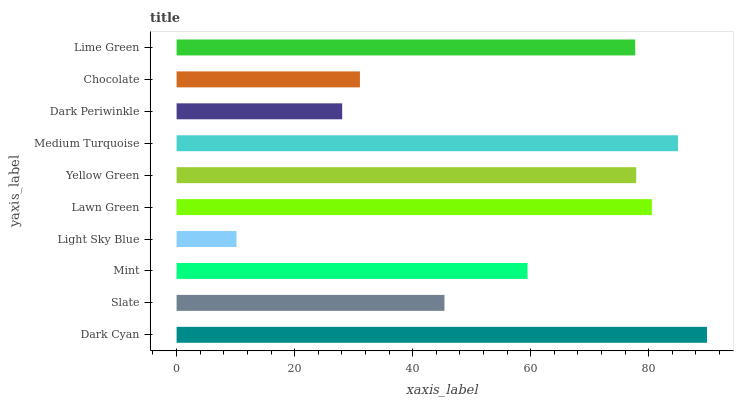Is Light Sky Blue the minimum?
Answer yes or no. Yes. Is Dark Cyan the maximum?
Answer yes or no. Yes. Is Slate the minimum?
Answer yes or no. No. Is Slate the maximum?
Answer yes or no. No. Is Dark Cyan greater than Slate?
Answer yes or no. Yes. Is Slate less than Dark Cyan?
Answer yes or no. Yes. Is Slate greater than Dark Cyan?
Answer yes or no. No. Is Dark Cyan less than Slate?
Answer yes or no. No. Is Lime Green the high median?
Answer yes or no. Yes. Is Mint the low median?
Answer yes or no. Yes. Is Dark Cyan the high median?
Answer yes or no. No. Is Lime Green the low median?
Answer yes or no. No. 